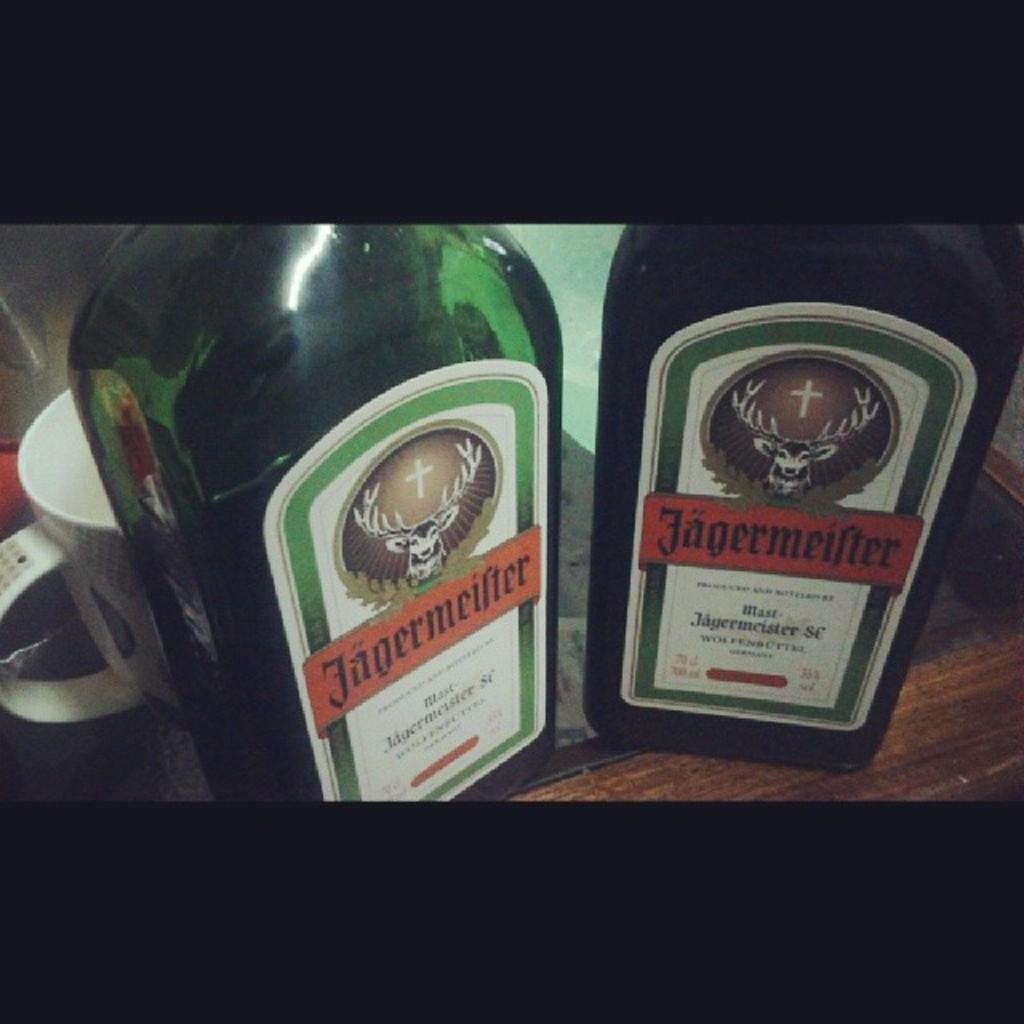Provide a one-sentence caption for the provided image. Two bottles of Jagermeister next to each other in front of a mug. 